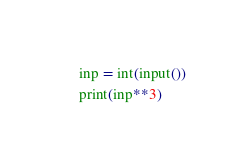Convert code to text. <code><loc_0><loc_0><loc_500><loc_500><_Python_>inp = int(input())
print(inp**3)</code> 